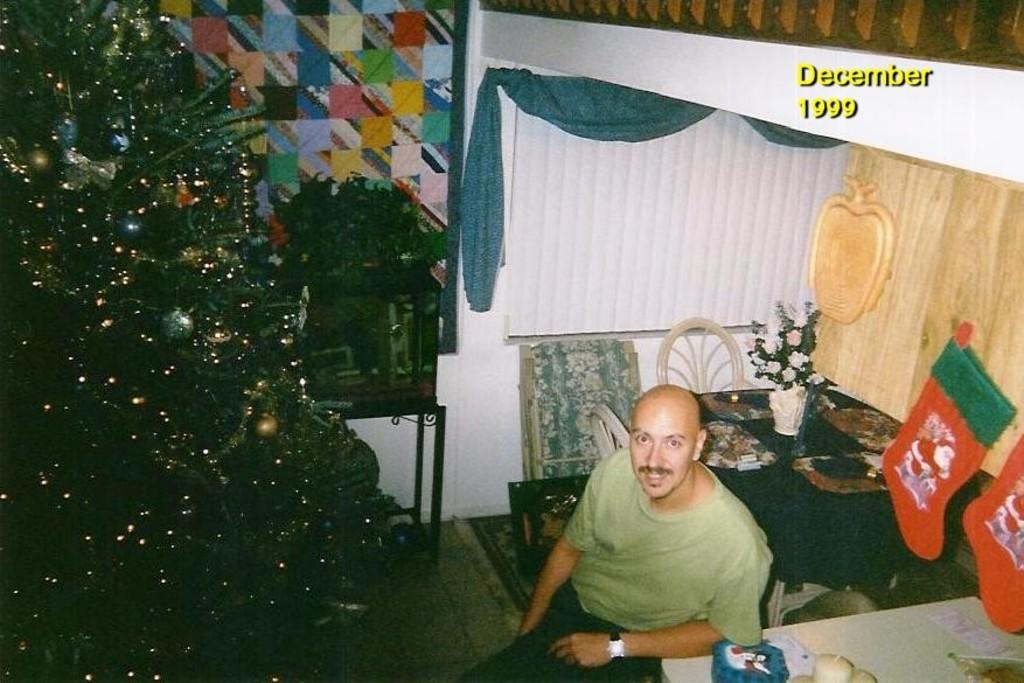Please provide a concise description of this image. In this image I can see the person with the green and black color dress. On both sides of the person I can see the tables. On the tables I can see the flower pot and some objects. To the right I can see the green and red color objects. In the background I can see the curtain. To the left I can see the tree. 